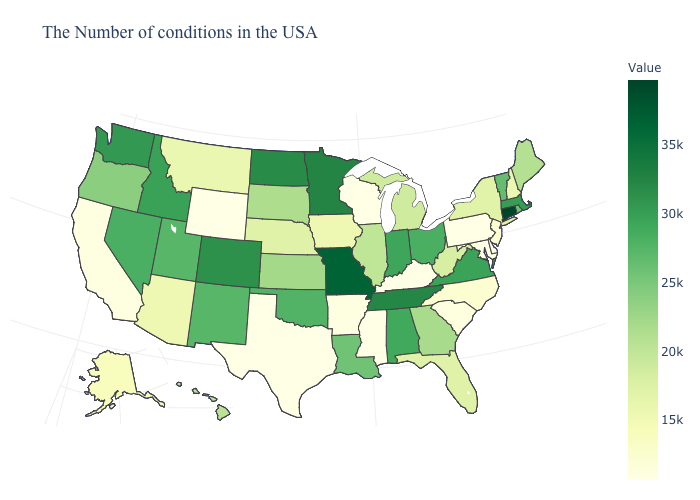Does the map have missing data?
Short answer required. No. Does New Jersey have the lowest value in the Northeast?
Keep it brief. No. Is the legend a continuous bar?
Be succinct. Yes. Does Pennsylvania have the lowest value in the Northeast?
Keep it brief. Yes. Does the map have missing data?
Concise answer only. No. Does Alabama have the highest value in the USA?
Keep it brief. No. Does Pennsylvania have a lower value than Nebraska?
Keep it brief. Yes. 